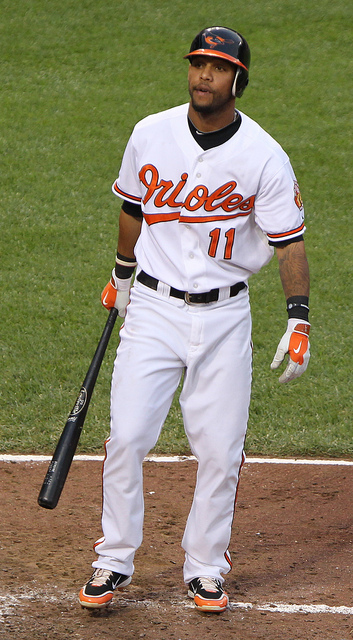Identify the text contained in this image. 11 rioles 